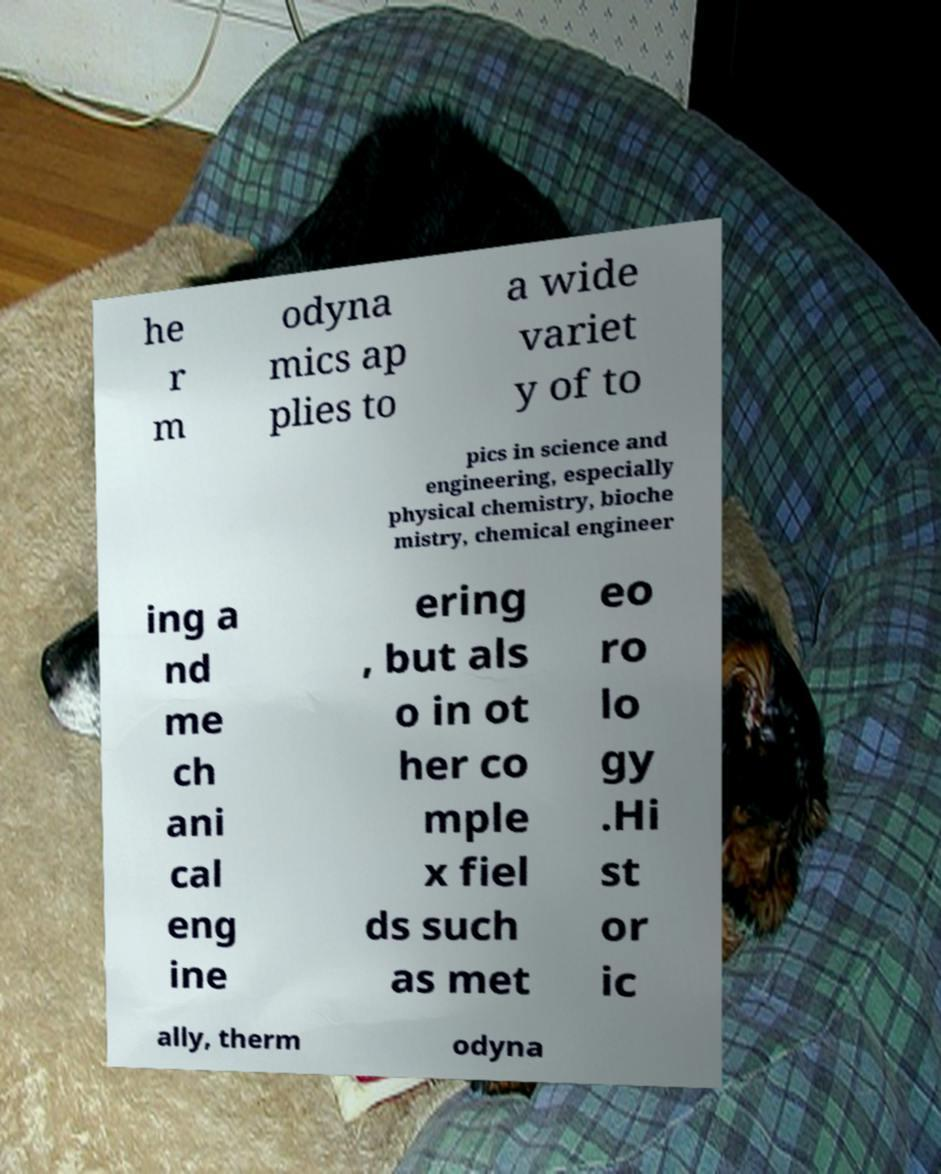Can you read and provide the text displayed in the image?This photo seems to have some interesting text. Can you extract and type it out for me? he r m odyna mics ap plies to a wide variet y of to pics in science and engineering, especially physical chemistry, bioche mistry, chemical engineer ing a nd me ch ani cal eng ine ering , but als o in ot her co mple x fiel ds such as met eo ro lo gy .Hi st or ic ally, therm odyna 